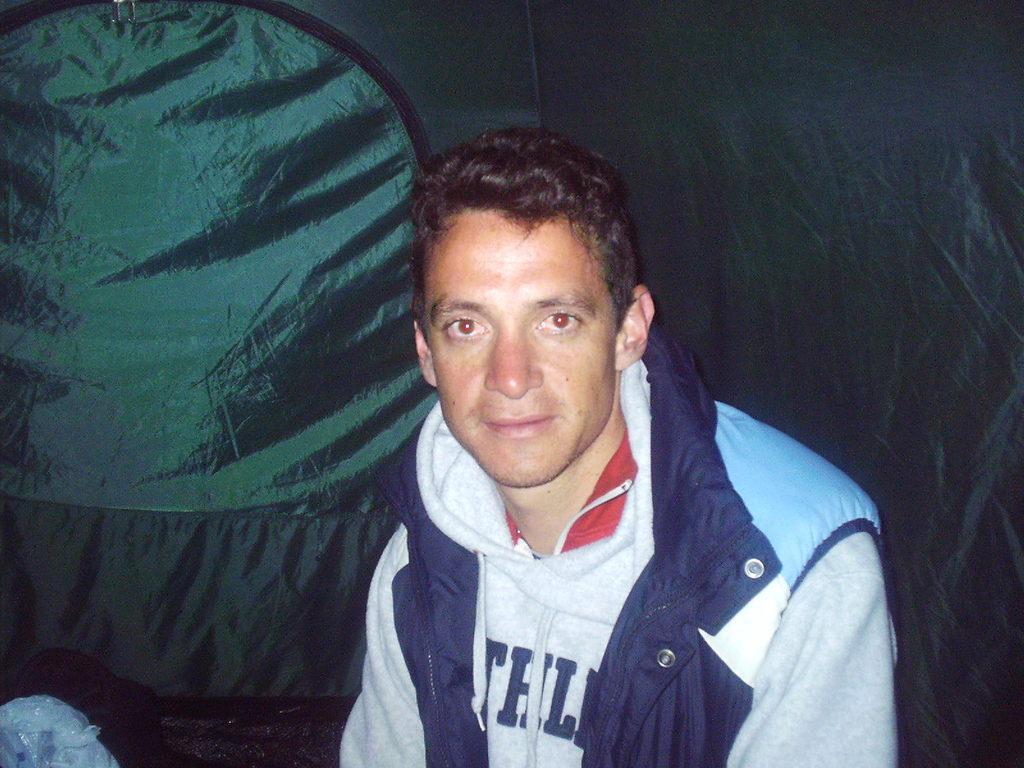Could you give a brief overview of what you see in this image? In the center of the image we can see a man. He is wearing a jacket. In the background we can see a curtain. 